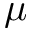Convert formula to latex. <formula><loc_0><loc_0><loc_500><loc_500>\mu</formula> 